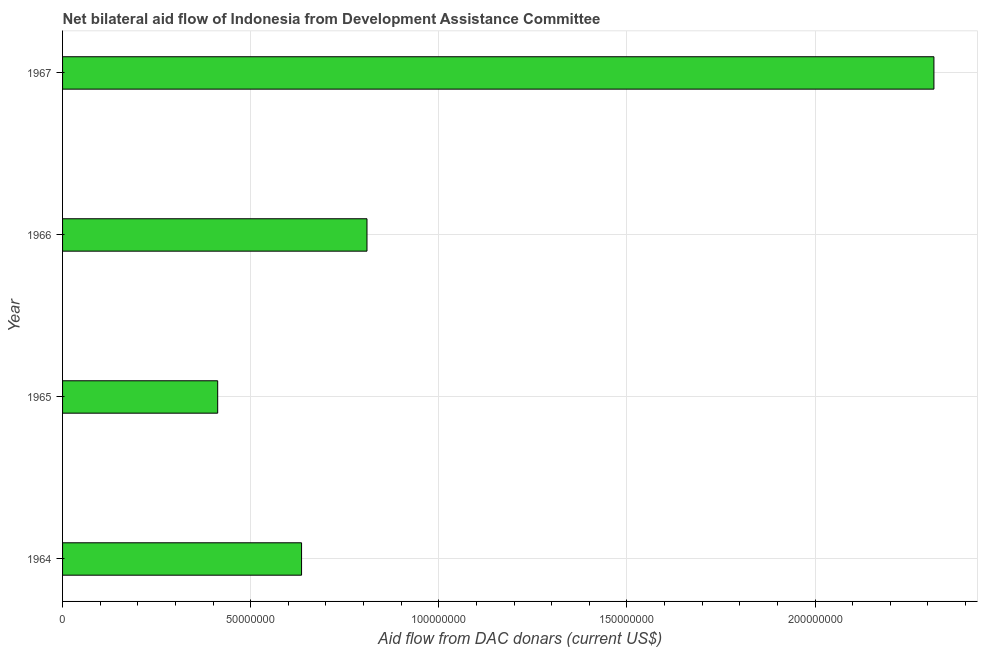Does the graph contain grids?
Ensure brevity in your answer.  Yes. What is the title of the graph?
Provide a succinct answer. Net bilateral aid flow of Indonesia from Development Assistance Committee. What is the label or title of the X-axis?
Your answer should be compact. Aid flow from DAC donars (current US$). What is the label or title of the Y-axis?
Give a very brief answer. Year. What is the net bilateral aid flows from dac donors in 1964?
Offer a terse response. 6.35e+07. Across all years, what is the maximum net bilateral aid flows from dac donors?
Your answer should be very brief. 2.32e+08. Across all years, what is the minimum net bilateral aid flows from dac donors?
Offer a very short reply. 4.12e+07. In which year was the net bilateral aid flows from dac donors maximum?
Give a very brief answer. 1967. In which year was the net bilateral aid flows from dac donors minimum?
Your answer should be very brief. 1965. What is the sum of the net bilateral aid flows from dac donors?
Give a very brief answer. 4.17e+08. What is the difference between the net bilateral aid flows from dac donors in 1965 and 1966?
Your response must be concise. -3.97e+07. What is the average net bilateral aid flows from dac donors per year?
Offer a terse response. 1.04e+08. What is the median net bilateral aid flows from dac donors?
Your answer should be compact. 7.22e+07. Do a majority of the years between 1966 and 1967 (inclusive) have net bilateral aid flows from dac donors greater than 30000000 US$?
Offer a terse response. Yes. What is the ratio of the net bilateral aid flows from dac donors in 1966 to that in 1967?
Offer a terse response. 0.35. Is the difference between the net bilateral aid flows from dac donors in 1965 and 1967 greater than the difference between any two years?
Provide a short and direct response. Yes. What is the difference between the highest and the second highest net bilateral aid flows from dac donors?
Your response must be concise. 1.51e+08. What is the difference between the highest and the lowest net bilateral aid flows from dac donors?
Keep it short and to the point. 1.90e+08. How many bars are there?
Your answer should be very brief. 4. Are all the bars in the graph horizontal?
Keep it short and to the point. Yes. What is the difference between two consecutive major ticks on the X-axis?
Give a very brief answer. 5.00e+07. Are the values on the major ticks of X-axis written in scientific E-notation?
Your answer should be very brief. No. What is the Aid flow from DAC donars (current US$) in 1964?
Offer a terse response. 6.35e+07. What is the Aid flow from DAC donars (current US$) of 1965?
Offer a very short reply. 4.12e+07. What is the Aid flow from DAC donars (current US$) of 1966?
Your answer should be compact. 8.09e+07. What is the Aid flow from DAC donars (current US$) in 1967?
Your response must be concise. 2.32e+08. What is the difference between the Aid flow from DAC donars (current US$) in 1964 and 1965?
Your answer should be compact. 2.23e+07. What is the difference between the Aid flow from DAC donars (current US$) in 1964 and 1966?
Offer a terse response. -1.74e+07. What is the difference between the Aid flow from DAC donars (current US$) in 1964 and 1967?
Offer a terse response. -1.68e+08. What is the difference between the Aid flow from DAC donars (current US$) in 1965 and 1966?
Offer a terse response. -3.97e+07. What is the difference between the Aid flow from DAC donars (current US$) in 1965 and 1967?
Your answer should be compact. -1.90e+08. What is the difference between the Aid flow from DAC donars (current US$) in 1966 and 1967?
Offer a very short reply. -1.51e+08. What is the ratio of the Aid flow from DAC donars (current US$) in 1964 to that in 1965?
Offer a terse response. 1.54. What is the ratio of the Aid flow from DAC donars (current US$) in 1964 to that in 1966?
Your answer should be compact. 0.79. What is the ratio of the Aid flow from DAC donars (current US$) in 1964 to that in 1967?
Your response must be concise. 0.27. What is the ratio of the Aid flow from DAC donars (current US$) in 1965 to that in 1966?
Your response must be concise. 0.51. What is the ratio of the Aid flow from DAC donars (current US$) in 1965 to that in 1967?
Give a very brief answer. 0.18. What is the ratio of the Aid flow from DAC donars (current US$) in 1966 to that in 1967?
Provide a succinct answer. 0.35. 